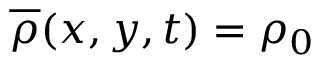<formula> <loc_0><loc_0><loc_500><loc_500>\overline { \rho } ( x , y , t ) = \rho _ { 0 }</formula> 